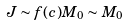<formula> <loc_0><loc_0><loc_500><loc_500>J \sim f ( c ) M _ { 0 } \sim M _ { 0 }</formula> 